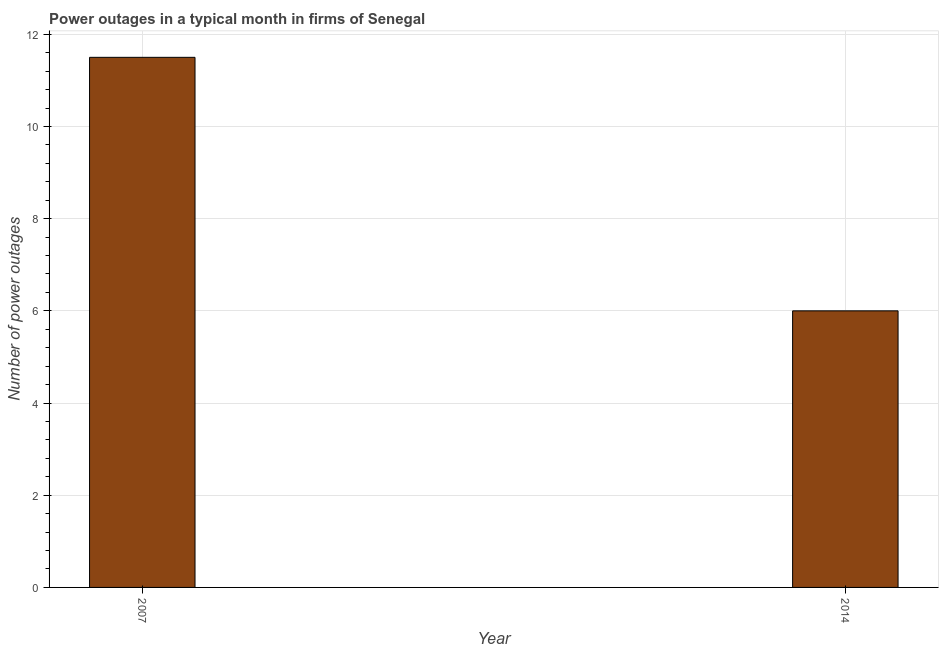Does the graph contain grids?
Offer a very short reply. Yes. What is the title of the graph?
Offer a terse response. Power outages in a typical month in firms of Senegal. What is the label or title of the X-axis?
Make the answer very short. Year. What is the label or title of the Y-axis?
Keep it short and to the point. Number of power outages. What is the number of power outages in 2007?
Your response must be concise. 11.5. Across all years, what is the maximum number of power outages?
Give a very brief answer. 11.5. Across all years, what is the minimum number of power outages?
Offer a terse response. 6. In which year was the number of power outages minimum?
Ensure brevity in your answer.  2014. What is the sum of the number of power outages?
Give a very brief answer. 17.5. What is the difference between the number of power outages in 2007 and 2014?
Your answer should be very brief. 5.5. What is the average number of power outages per year?
Provide a short and direct response. 8.75. What is the median number of power outages?
Your answer should be compact. 8.75. In how many years, is the number of power outages greater than 9.2 ?
Offer a very short reply. 1. Do a majority of the years between 2014 and 2007 (inclusive) have number of power outages greater than 1.6 ?
Your answer should be very brief. No. What is the ratio of the number of power outages in 2007 to that in 2014?
Provide a succinct answer. 1.92. Is the number of power outages in 2007 less than that in 2014?
Keep it short and to the point. No. In how many years, is the number of power outages greater than the average number of power outages taken over all years?
Your answer should be compact. 1. How many bars are there?
Ensure brevity in your answer.  2. What is the Number of power outages of 2014?
Make the answer very short. 6. What is the difference between the Number of power outages in 2007 and 2014?
Offer a very short reply. 5.5. What is the ratio of the Number of power outages in 2007 to that in 2014?
Offer a terse response. 1.92. 